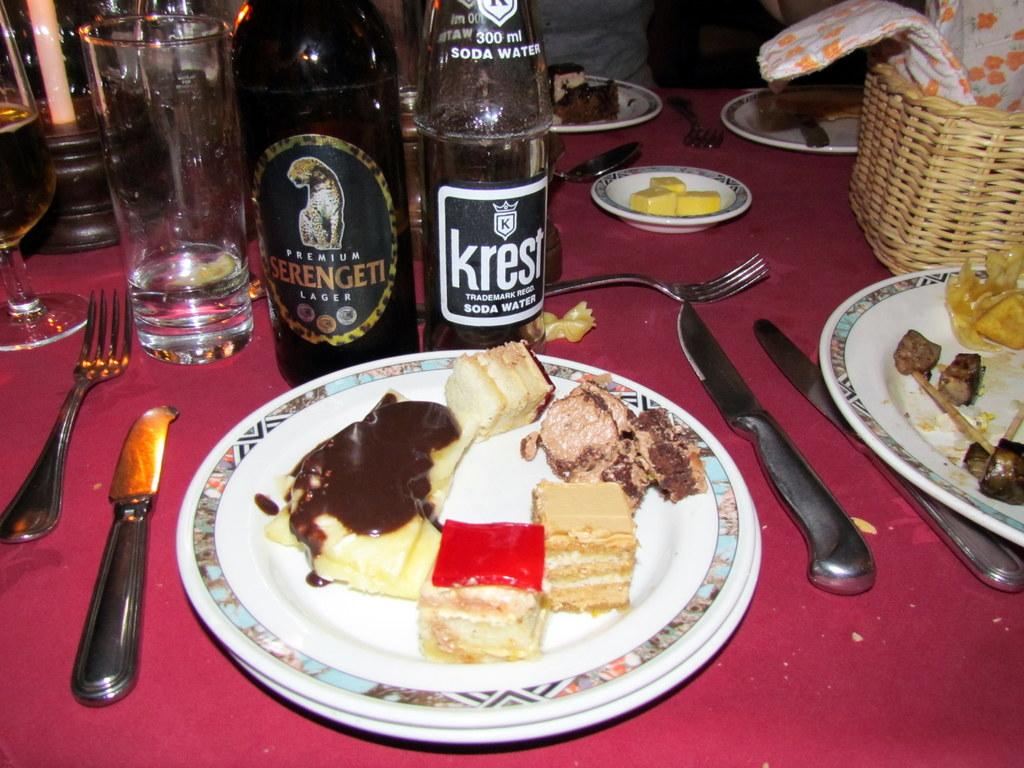What is the name of the soda water brand?
Ensure brevity in your answer.  Krest. 